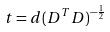Convert formula to latex. <formula><loc_0><loc_0><loc_500><loc_500>t = d ( D ^ { T } D ) ^ { - \frac { 1 } { 2 } }</formula> 